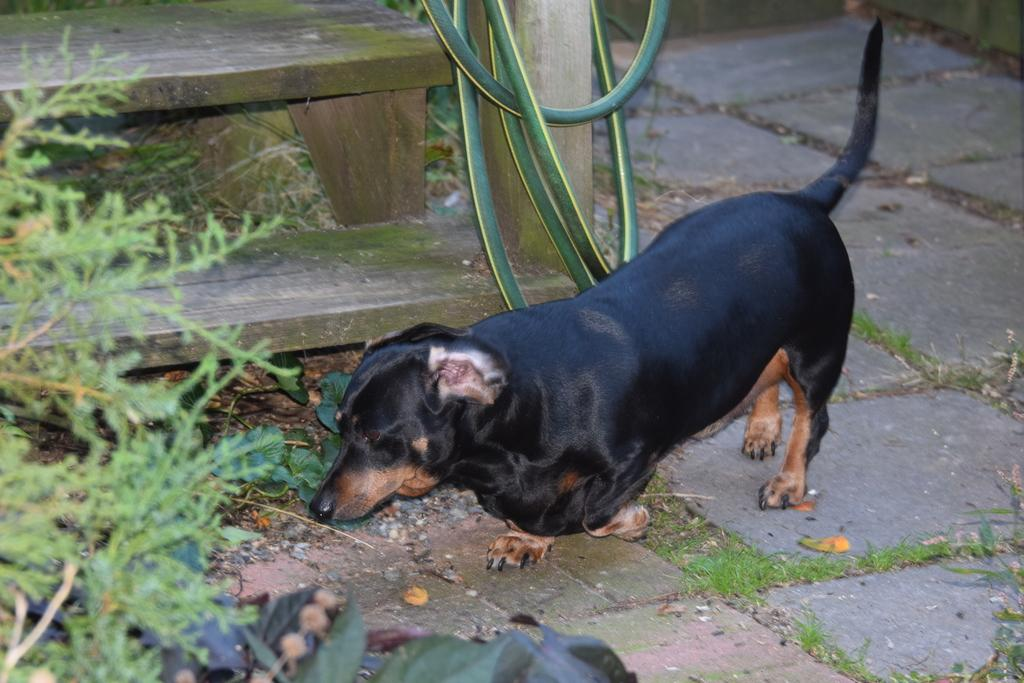What animal can be seen on the ground in the image? There is a dog on the ground in the image. What type of vegetation is on the left side of the image? There are plants on the left side of the image. What material is the plank in the background of the image made of? The wooden plank in the background of the image is made of wood. What object can be seen in the background of the image? There is a pipe in the background of the image. What type of cakes are being served in the scene? There is no scene or cakes present in the image; it features a dog, plants, a wooden plank, and a pipe. 